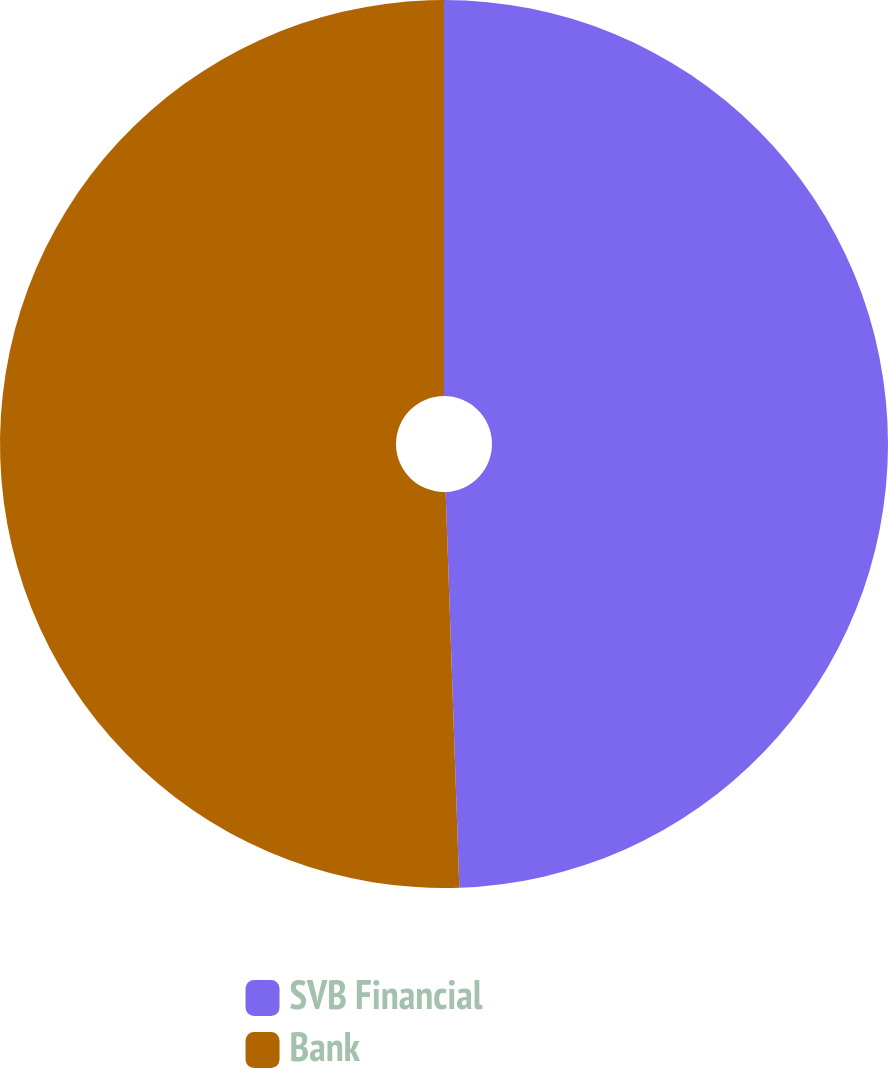Convert chart to OTSL. <chart><loc_0><loc_0><loc_500><loc_500><pie_chart><fcel>SVB Financial<fcel>Bank<nl><fcel>49.45%<fcel>50.55%<nl></chart> 